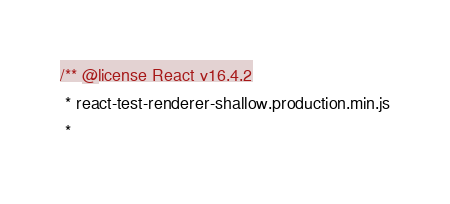<code> <loc_0><loc_0><loc_500><loc_500><_JavaScript_>/** @license React v16.4.2
 * react-test-renderer-shallow.production.min.js
 *</code> 